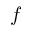Convert formula to latex. <formula><loc_0><loc_0><loc_500><loc_500>f</formula> 